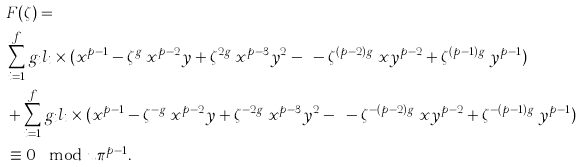Convert formula to latex. <formula><loc_0><loc_0><loc_500><loc_500>& F ( \zeta ) = \\ & \sum _ { i = 1 } ^ { f } g _ { i } l _ { i } \times ( x ^ { p - 1 } - \zeta ^ { g _ { i } } x ^ { p - 2 } y + \zeta ^ { 2 g _ { i } } x ^ { p - 3 } y ^ { 2 } - \dots - \zeta ^ { ( p - 2 ) g _ { i } } x y ^ { p - 2 } + \zeta ^ { ( p - 1 ) g _ { i } } y ^ { p - 1 } ) \\ & + \sum _ { i = 1 } ^ { f } g _ { i } l _ { i } \times ( x ^ { p - 1 } - \zeta ^ { - g _ { i } } x ^ { p - 2 } y + \zeta ^ { - 2 g _ { i } } x ^ { p - 3 } y ^ { 2 } - \dots - \zeta ^ { - ( p - 2 ) g _ { i } } x y ^ { p - 2 } + \zeta ^ { - ( p - 1 ) g _ { i } } y ^ { p - 1 } ) \\ & \equiv 0 \mod u \pi ^ { p - 1 } .</formula> 